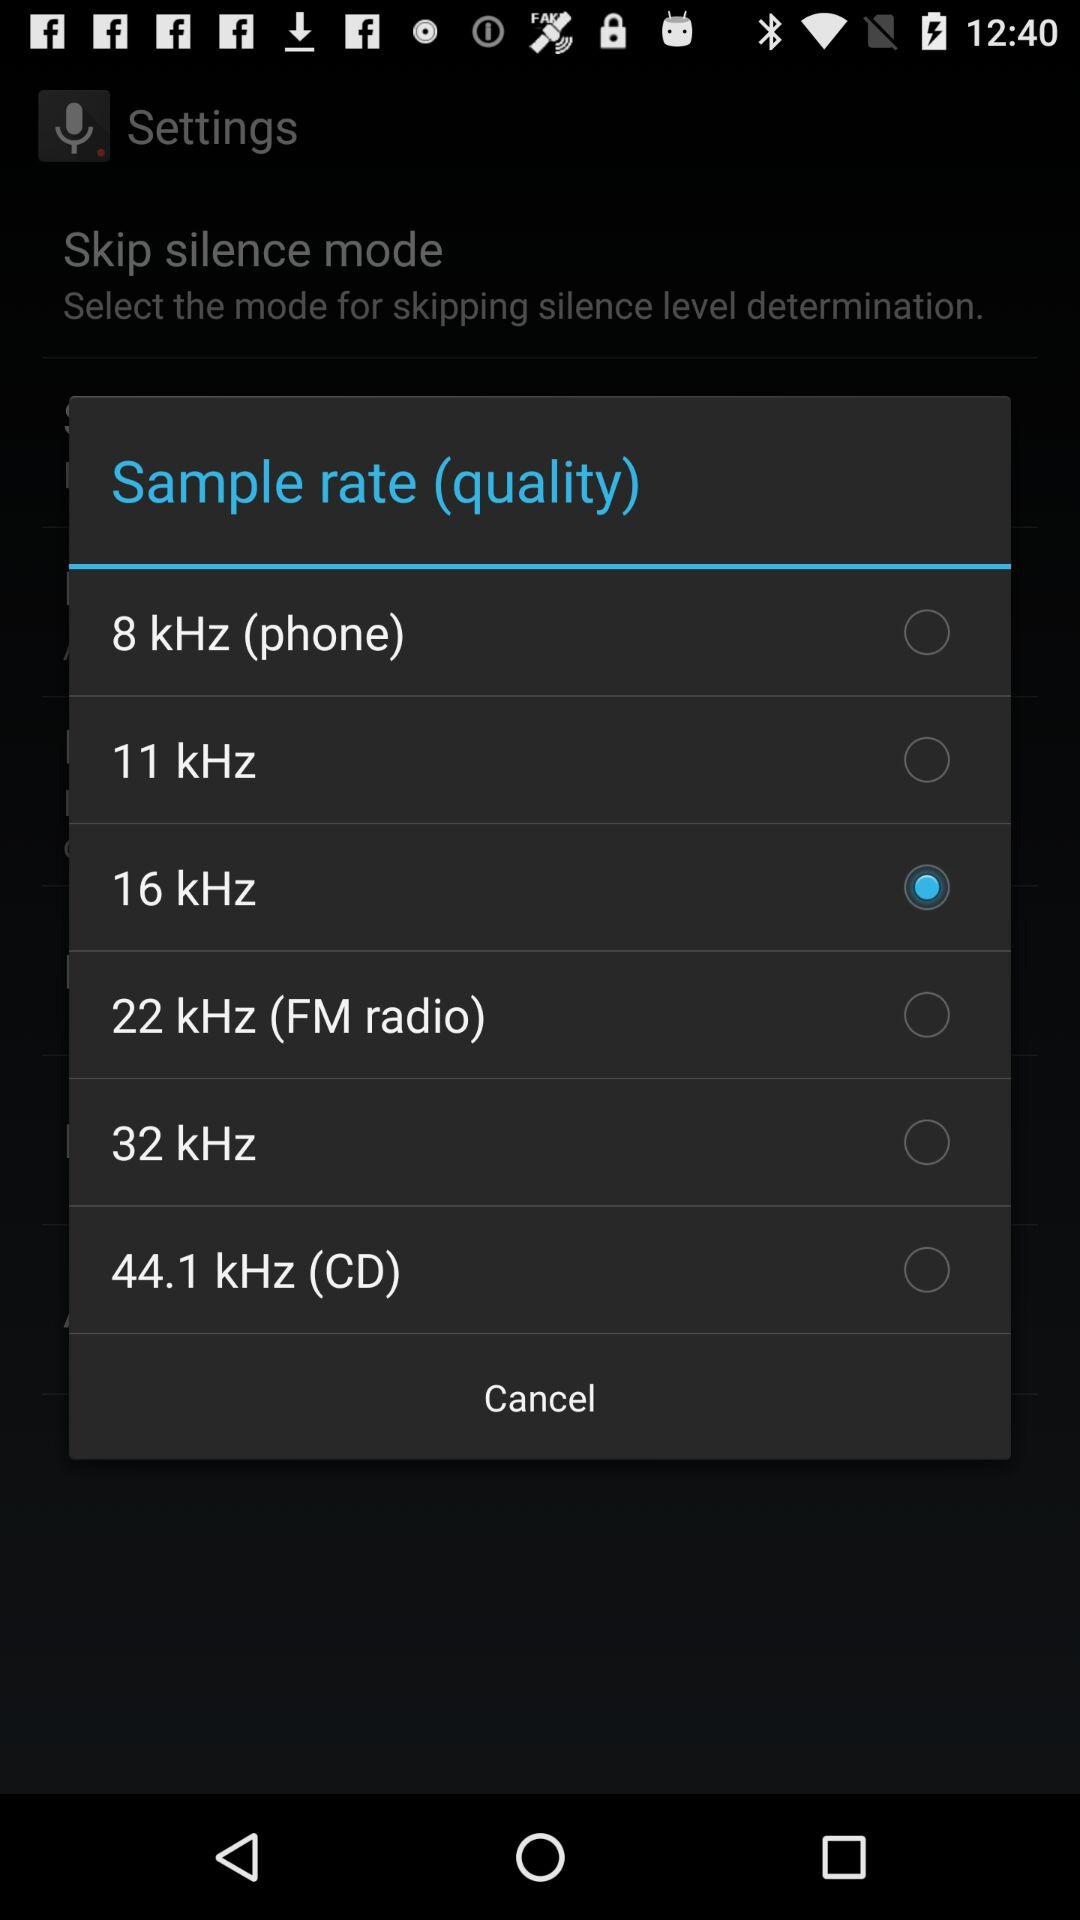Is "11 kHz" selected or not?
Answer the question using a single word or phrase. It's not selected. 